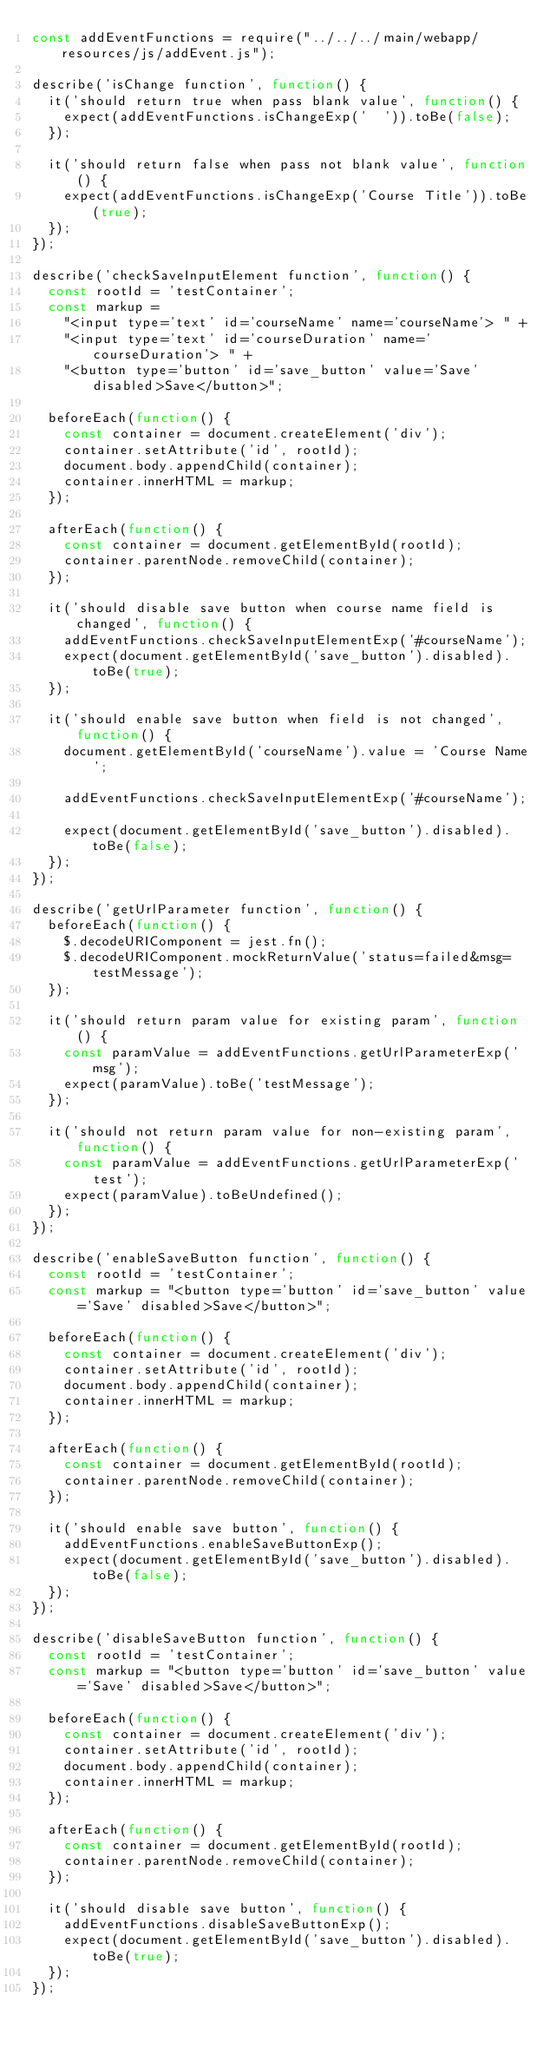Convert code to text. <code><loc_0><loc_0><loc_500><loc_500><_JavaScript_>const addEventFunctions = require("../../../main/webapp/resources/js/addEvent.js");

describe('isChange function', function() {
  it('should return true when pass blank value', function() {
    expect(addEventFunctions.isChangeExp('  ')).toBe(false);
  });

  it('should return false when pass not blank value', function() {
    expect(addEventFunctions.isChangeExp('Course Title')).toBe(true);
  });
});

describe('checkSaveInputElement function', function() {
  const rootId = 'testContainer';
  const markup =
    "<input type='text' id='courseName' name='courseName'> " +
    "<input type='text' id='courseDuration' name='courseDuration'> " +
    "<button type='button' id='save_button' value='Save' disabled>Save</button>";

  beforeEach(function() {
    const container = document.createElement('div');
    container.setAttribute('id', rootId);
    document.body.appendChild(container);
    container.innerHTML = markup;
  });

  afterEach(function() {
    const container = document.getElementById(rootId);
    container.parentNode.removeChild(container);
  });

  it('should disable save button when course name field is changed', function() {
    addEventFunctions.checkSaveInputElementExp('#courseName');
    expect(document.getElementById('save_button').disabled).toBe(true);
  });

  it('should enable save button when field is not changed', function() {
    document.getElementById('courseName').value = 'Course Name';

    addEventFunctions.checkSaveInputElementExp('#courseName');

    expect(document.getElementById('save_button').disabled).toBe(false);
  });
});

describe('getUrlParameter function', function() {
  beforeEach(function() {
    $.decodeURIComponent = jest.fn();
    $.decodeURIComponent.mockReturnValue('status=failed&msg=testMessage');
  });

  it('should return param value for existing param', function() {
    const paramValue = addEventFunctions.getUrlParameterExp('msg');
    expect(paramValue).toBe('testMessage');
  });

  it('should not return param value for non-existing param', function() {
    const paramValue = addEventFunctions.getUrlParameterExp('test');
    expect(paramValue).toBeUndefined();
  });
});

describe('enableSaveButton function', function() {
  const rootId = 'testContainer';
  const markup = "<button type='button' id='save_button' value='Save' disabled>Save</button>";

  beforeEach(function() {
    const container = document.createElement('div');
    container.setAttribute('id', rootId);
    document.body.appendChild(container);
    container.innerHTML = markup;
  });

  afterEach(function() {
    const container = document.getElementById(rootId);
    container.parentNode.removeChild(container);
  });

  it('should enable save button', function() {
    addEventFunctions.enableSaveButtonExp();
    expect(document.getElementById('save_button').disabled).toBe(false);
  });
});

describe('disableSaveButton function', function() {
  const rootId = 'testContainer';
  const markup = "<button type='button' id='save_button' value='Save' disabled>Save</button>";

  beforeEach(function() {
    const container = document.createElement('div');
    container.setAttribute('id', rootId);
    document.body.appendChild(container);
    container.innerHTML = markup;
  });

  afterEach(function() {
    const container = document.getElementById(rootId);
    container.parentNode.removeChild(container);
  });

  it('should disable save button', function() {
    addEventFunctions.disableSaveButtonExp();
    expect(document.getElementById('save_button').disabled).toBe(true);
  });
});
</code> 